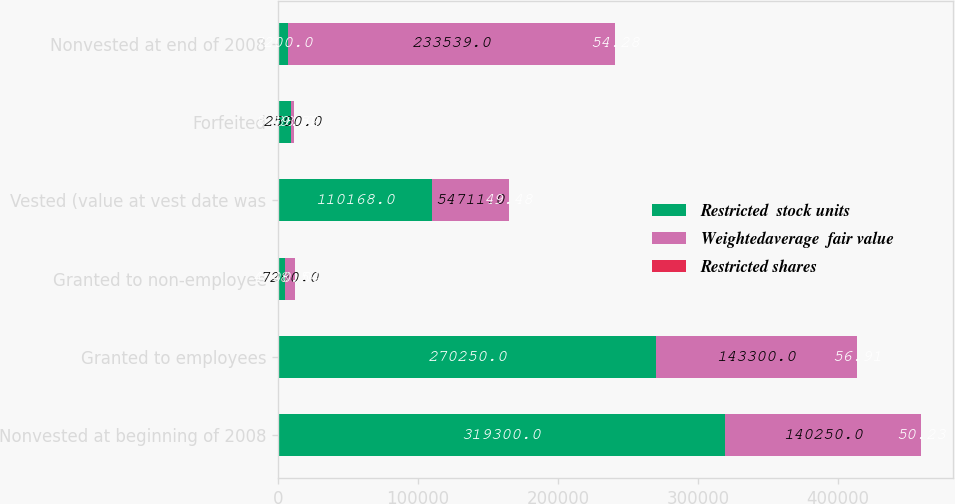Convert chart. <chart><loc_0><loc_0><loc_500><loc_500><stacked_bar_chart><ecel><fcel>Nonvested at beginning of 2008<fcel>Granted to employees<fcel>Granted to non-employee<fcel>Vested (value at vest date was<fcel>Forfeited<fcel>Nonvested at end of 2008<nl><fcel>Restricted  stock units<fcel>319300<fcel>270250<fcel>4800<fcel>110168<fcel>8988<fcel>7200<nl><fcel>Weightedaverage  fair value<fcel>140250<fcel>143300<fcel>7200<fcel>54711<fcel>2500<fcel>233539<nl><fcel>Restricted shares<fcel>50.23<fcel>56.91<fcel>48.54<fcel>49.48<fcel>49.52<fcel>54.28<nl></chart> 